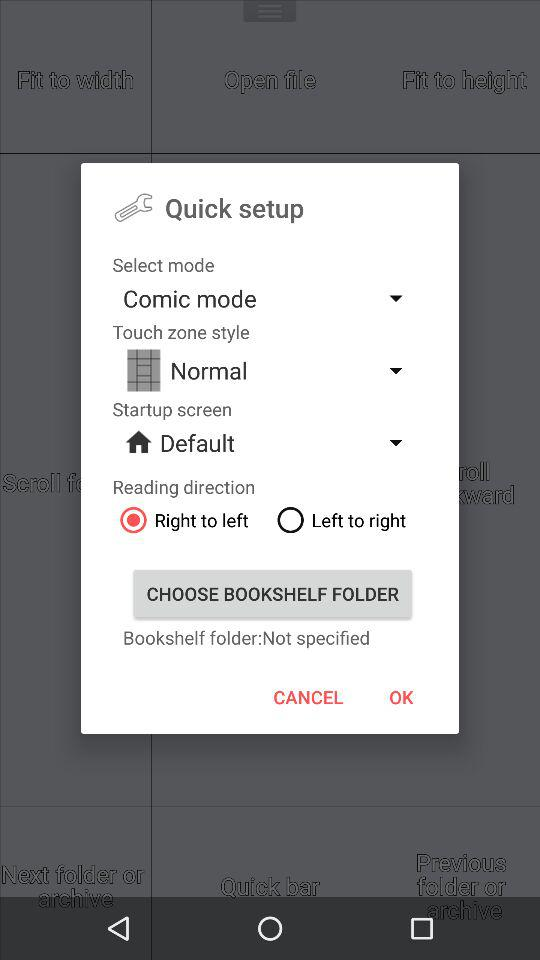Which type of reading direction is selected? The selected type of reading direction is "Right to left". 